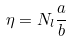<formula> <loc_0><loc_0><loc_500><loc_500>\eta = N _ { l } \frac { a } { b }</formula> 